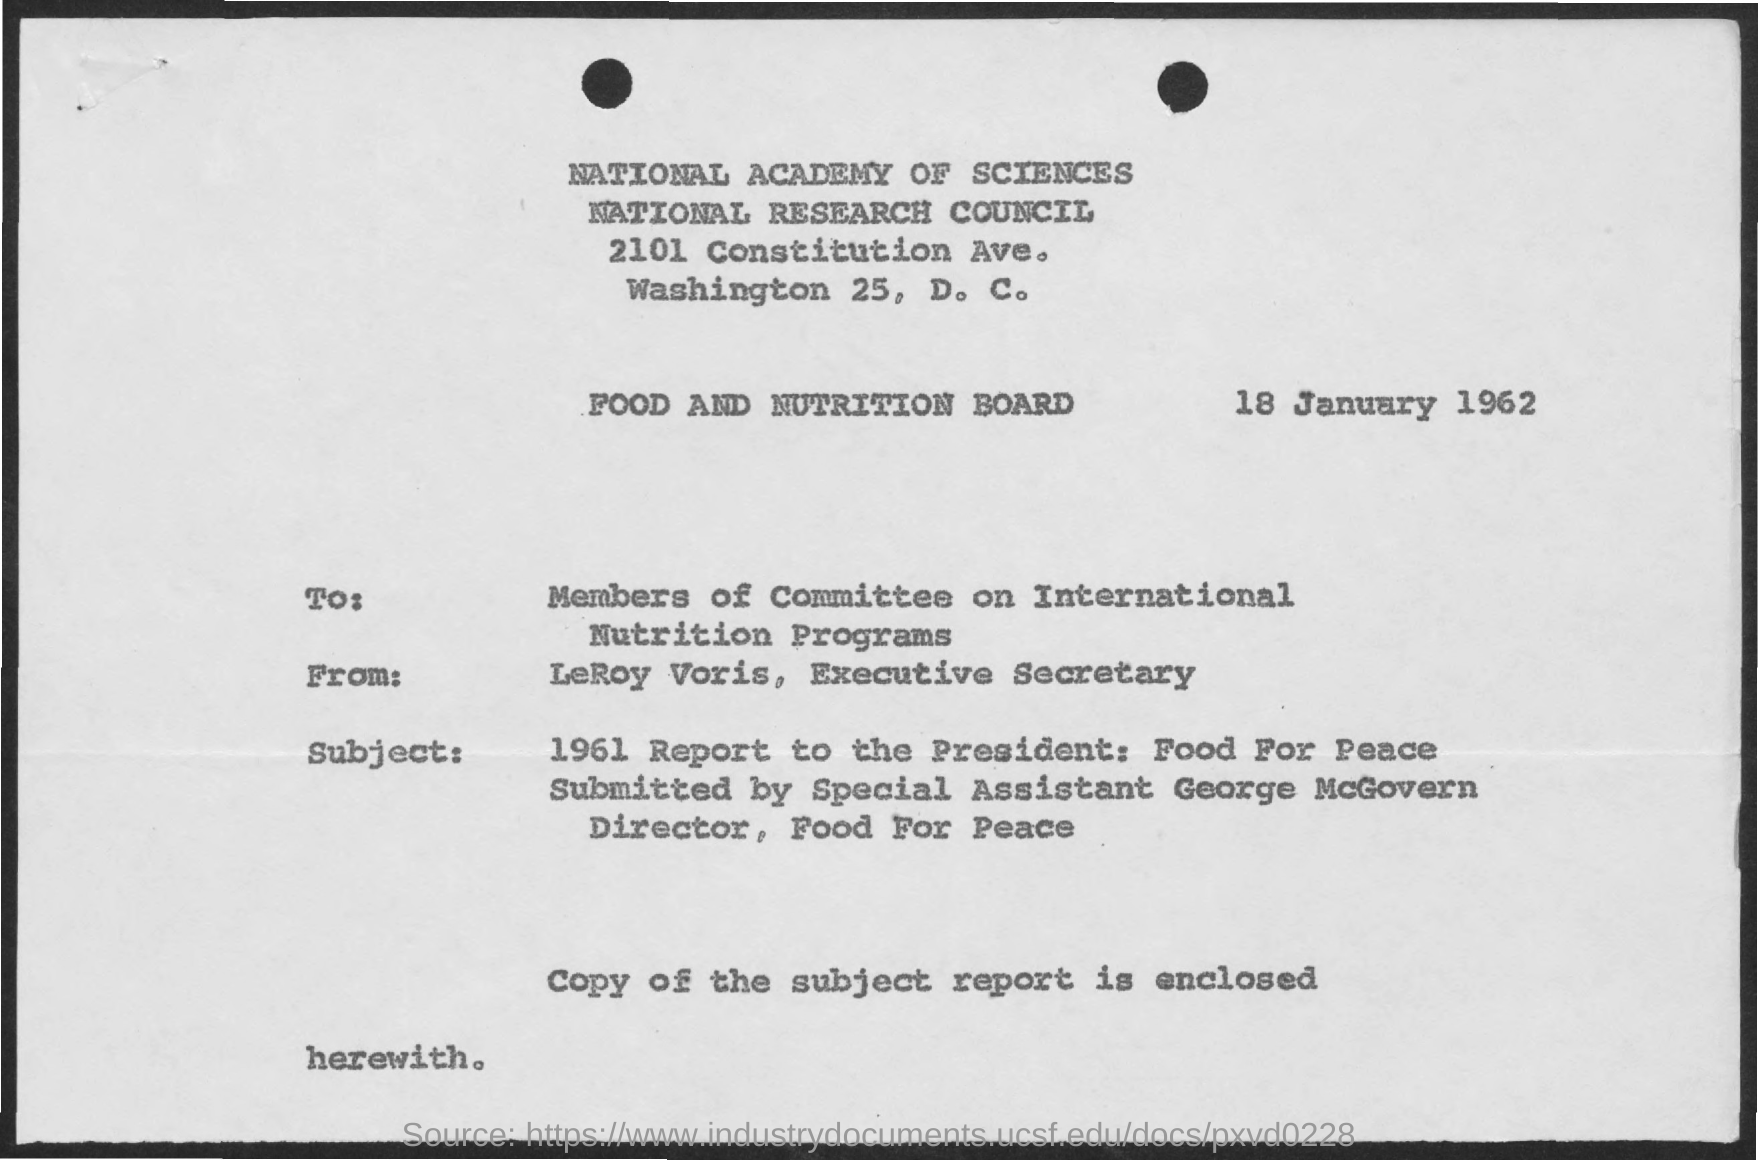What is the date mentioned in this document?
Your response must be concise. 18 January 1962. To whom, the document is addressed?
Offer a very short reply. Members of Committee on International Nutrition Programs. Who is the sender of this document?
Offer a very short reply. LeRoy Voris. Which copy is enclosed with this document?
Give a very brief answer. Copy of the subject report. 